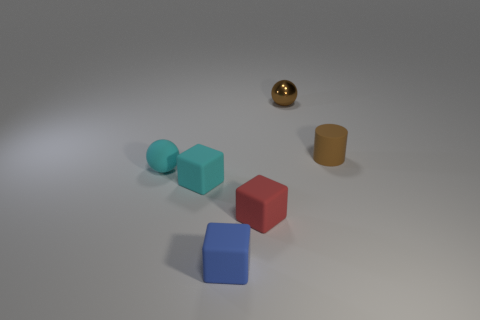Add 1 small red things. How many objects exist? 7 Subtract all cylinders. How many objects are left? 5 Add 3 small cyan spheres. How many small cyan spheres exist? 4 Subtract 0 brown blocks. How many objects are left? 6 Subtract all small yellow metallic blocks. Subtract all tiny cyan cubes. How many objects are left? 5 Add 1 tiny brown things. How many tiny brown things are left? 3 